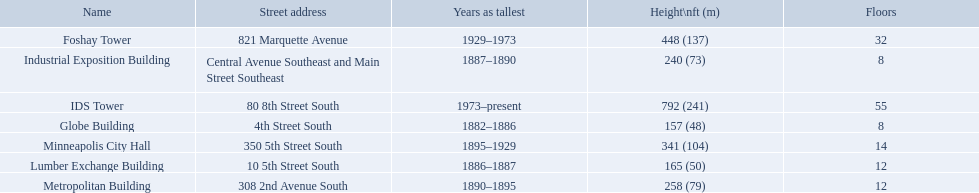Which buildings have the same number of floors as another building? Globe Building, Lumber Exchange Building, Industrial Exposition Building, Metropolitan Building. Of those, which has the same as the lumber exchange building? Metropolitan Building. 